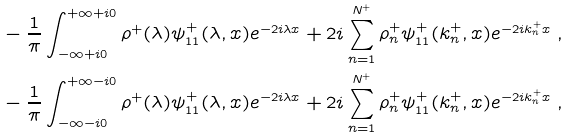Convert formula to latex. <formula><loc_0><loc_0><loc_500><loc_500>& - \frac { 1 } { \pi } \int _ { - \infty + i 0 } ^ { + \infty + i 0 } \rho ^ { + } ( \lambda ) \psi _ { 1 1 } ^ { + } ( \lambda , x ) e ^ { - 2 i \lambda x } + 2 i \sum _ { n = 1 } ^ { N ^ { + } } \rho _ { n } ^ { + } \psi _ { 1 1 } ^ { + } ( k _ { n } ^ { + } , x ) e ^ { - 2 i k _ { n } ^ { + } x } \ , \\ & - \frac { 1 } { \pi } \int _ { - \infty - i 0 } ^ { + \infty - i 0 } \rho ^ { + } ( \lambda ) \psi _ { 1 1 } ^ { + } ( \lambda , x ) e ^ { - 2 i \lambda x } + 2 i \sum _ { n = 1 } ^ { N ^ { + } } \rho _ { n } ^ { + } \psi _ { 1 1 } ^ { + } ( k _ { n } ^ { + } , x ) e ^ { - 2 i k _ { n } ^ { + } x } \ ,</formula> 